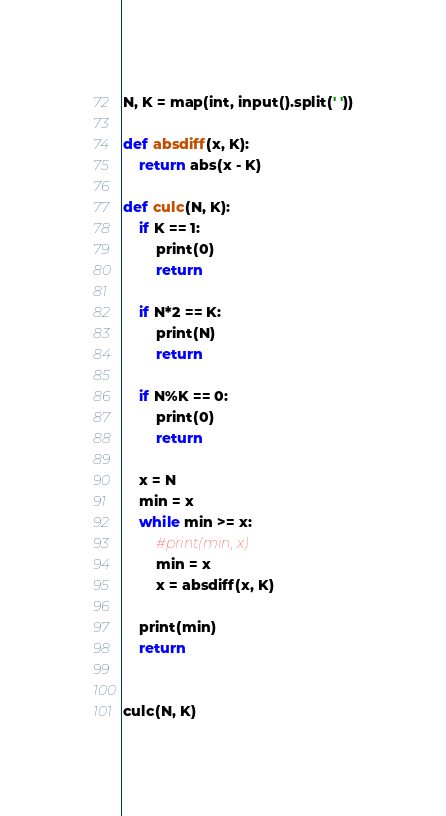<code> <loc_0><loc_0><loc_500><loc_500><_Python_>N, K = map(int, input().split(' '))

def absdiff(x, K):
    return abs(x - K)

def culc(N, K):
    if K == 1:
        print(0)
        return

    if N*2 == K:
        print(N)
        return

    if N%K == 0:
        print(0)
        return

    x = N
    min = x
    while min >= x:
        #print(min, x)
        min = x
        x = absdiff(x, K)

    print(min)
    return


culc(N, K)
</code> 